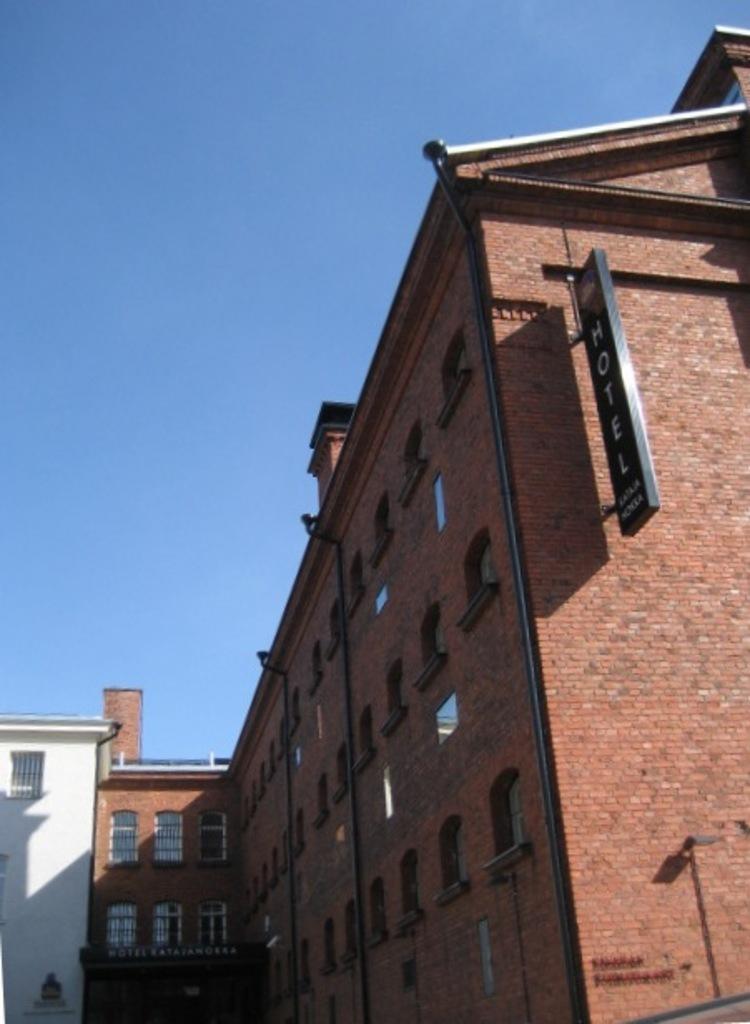Describe this image in one or two sentences. In this image we can see some buildings which are in red and white color and top of the image there is clear sky. 